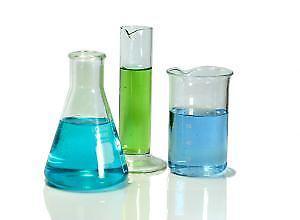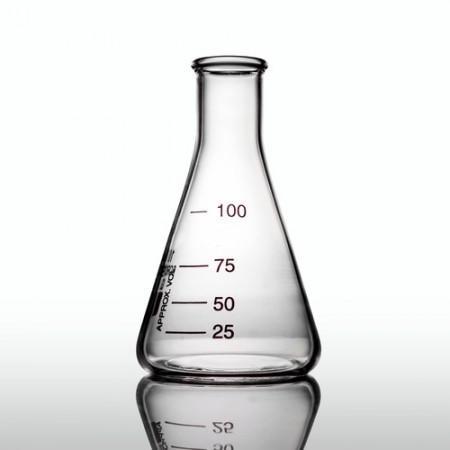The first image is the image on the left, the second image is the image on the right. Examine the images to the left and right. Is the description "An image contains just one beaker, which is cylinder shaped." accurate? Answer yes or no. No. The first image is the image on the left, the second image is the image on the right. Analyze the images presented: Is the assertion "One or more beakers in one image are partially filled with colored liquid, while the one beaker in the other image is triangular shaped and empty." valid? Answer yes or no. Yes. 